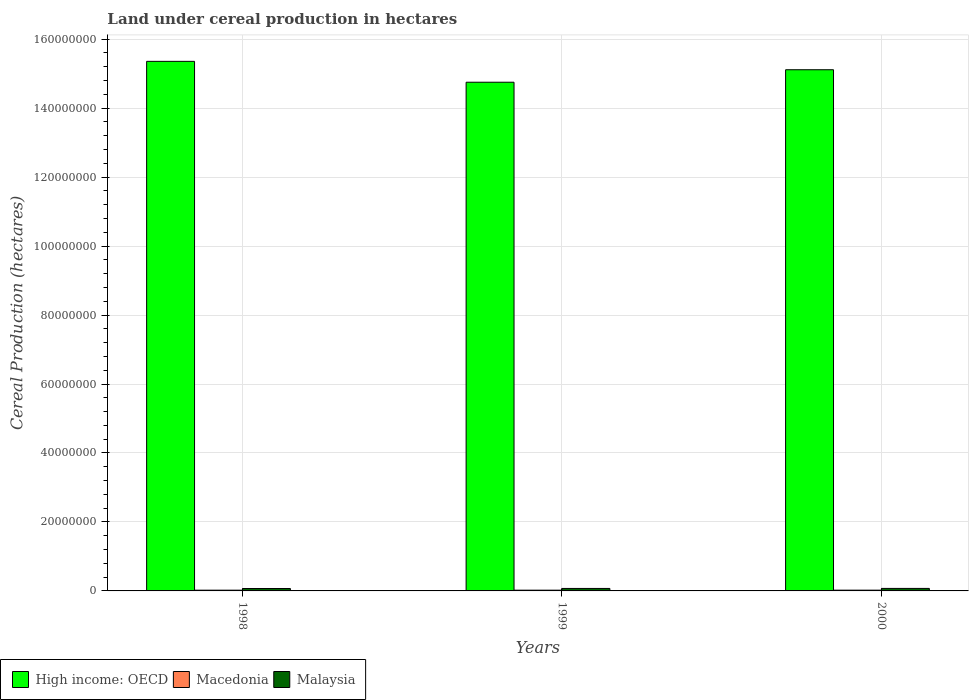How many groups of bars are there?
Provide a succinct answer. 3. Are the number of bars per tick equal to the number of legend labels?
Provide a short and direct response. Yes. Are the number of bars on each tick of the X-axis equal?
Your answer should be compact. Yes. How many bars are there on the 3rd tick from the right?
Offer a very short reply. 3. What is the label of the 3rd group of bars from the left?
Give a very brief answer. 2000. In how many cases, is the number of bars for a given year not equal to the number of legend labels?
Offer a very short reply. 0. What is the land under cereal production in Malaysia in 1998?
Give a very brief answer. 7.01e+05. Across all years, what is the maximum land under cereal production in Macedonia?
Your answer should be very brief. 2.20e+05. Across all years, what is the minimum land under cereal production in Macedonia?
Keep it short and to the point. 2.14e+05. In which year was the land under cereal production in Malaysia maximum?
Give a very brief answer. 2000. What is the total land under cereal production in High income: OECD in the graph?
Make the answer very short. 4.52e+08. What is the difference between the land under cereal production in Macedonia in 1998 and that in 2000?
Keep it short and to the point. -5616. What is the difference between the land under cereal production in High income: OECD in 2000 and the land under cereal production in Malaysia in 1999?
Give a very brief answer. 1.50e+08. What is the average land under cereal production in Malaysia per year?
Provide a short and direct response. 7.15e+05. In the year 1998, what is the difference between the land under cereal production in High income: OECD and land under cereal production in Macedonia?
Provide a short and direct response. 1.53e+08. In how many years, is the land under cereal production in High income: OECD greater than 28000000 hectares?
Your answer should be very brief. 3. What is the ratio of the land under cereal production in Macedonia in 1999 to that in 2000?
Your answer should be compact. 0.99. What is the difference between the highest and the second highest land under cereal production in Macedonia?
Provide a short and direct response. 2977. What is the difference between the highest and the lowest land under cereal production in Malaysia?
Provide a succinct answer. 2.43e+04. Is the sum of the land under cereal production in High income: OECD in 1999 and 2000 greater than the maximum land under cereal production in Malaysia across all years?
Keep it short and to the point. Yes. What does the 1st bar from the left in 1999 represents?
Your response must be concise. High income: OECD. What does the 1st bar from the right in 1998 represents?
Your answer should be compact. Malaysia. Is it the case that in every year, the sum of the land under cereal production in High income: OECD and land under cereal production in Macedonia is greater than the land under cereal production in Malaysia?
Offer a very short reply. Yes. Are all the bars in the graph horizontal?
Your answer should be very brief. No. How many years are there in the graph?
Keep it short and to the point. 3. Are the values on the major ticks of Y-axis written in scientific E-notation?
Keep it short and to the point. No. Does the graph contain any zero values?
Provide a short and direct response. No. Where does the legend appear in the graph?
Your answer should be compact. Bottom left. What is the title of the graph?
Provide a succinct answer. Land under cereal production in hectares. Does "Peru" appear as one of the legend labels in the graph?
Keep it short and to the point. No. What is the label or title of the Y-axis?
Your response must be concise. Cereal Production (hectares). What is the Cereal Production (hectares) of High income: OECD in 1998?
Ensure brevity in your answer.  1.54e+08. What is the Cereal Production (hectares) of Macedonia in 1998?
Offer a terse response. 2.14e+05. What is the Cereal Production (hectares) of Malaysia in 1998?
Provide a short and direct response. 7.01e+05. What is the Cereal Production (hectares) of High income: OECD in 1999?
Offer a terse response. 1.48e+08. What is the Cereal Production (hectares) of Macedonia in 1999?
Offer a very short reply. 2.17e+05. What is the Cereal Production (hectares) in Malaysia in 1999?
Your response must be concise. 7.19e+05. What is the Cereal Production (hectares) of High income: OECD in 2000?
Your answer should be very brief. 1.51e+08. What is the Cereal Production (hectares) in Macedonia in 2000?
Ensure brevity in your answer.  2.20e+05. What is the Cereal Production (hectares) of Malaysia in 2000?
Ensure brevity in your answer.  7.26e+05. Across all years, what is the maximum Cereal Production (hectares) of High income: OECD?
Provide a short and direct response. 1.54e+08. Across all years, what is the maximum Cereal Production (hectares) of Macedonia?
Offer a very short reply. 2.20e+05. Across all years, what is the maximum Cereal Production (hectares) of Malaysia?
Make the answer very short. 7.26e+05. Across all years, what is the minimum Cereal Production (hectares) of High income: OECD?
Your answer should be compact. 1.48e+08. Across all years, what is the minimum Cereal Production (hectares) of Macedonia?
Provide a succinct answer. 2.14e+05. Across all years, what is the minimum Cereal Production (hectares) of Malaysia?
Your answer should be compact. 7.01e+05. What is the total Cereal Production (hectares) in High income: OECD in the graph?
Provide a short and direct response. 4.52e+08. What is the total Cereal Production (hectares) in Macedonia in the graph?
Your response must be concise. 6.51e+05. What is the total Cereal Production (hectares) in Malaysia in the graph?
Your response must be concise. 2.15e+06. What is the difference between the Cereal Production (hectares) in High income: OECD in 1998 and that in 1999?
Give a very brief answer. 6.05e+06. What is the difference between the Cereal Production (hectares) in Macedonia in 1998 and that in 1999?
Offer a terse response. -2639. What is the difference between the Cereal Production (hectares) in Malaysia in 1998 and that in 1999?
Offer a terse response. -1.80e+04. What is the difference between the Cereal Production (hectares) in High income: OECD in 1998 and that in 2000?
Give a very brief answer. 2.43e+06. What is the difference between the Cereal Production (hectares) in Macedonia in 1998 and that in 2000?
Your response must be concise. -5616. What is the difference between the Cereal Production (hectares) of Malaysia in 1998 and that in 2000?
Your response must be concise. -2.43e+04. What is the difference between the Cereal Production (hectares) in High income: OECD in 1999 and that in 2000?
Your answer should be very brief. -3.62e+06. What is the difference between the Cereal Production (hectares) of Macedonia in 1999 and that in 2000?
Provide a succinct answer. -2977. What is the difference between the Cereal Production (hectares) in Malaysia in 1999 and that in 2000?
Your response must be concise. -6311. What is the difference between the Cereal Production (hectares) in High income: OECD in 1998 and the Cereal Production (hectares) in Macedonia in 1999?
Your answer should be very brief. 1.53e+08. What is the difference between the Cereal Production (hectares) of High income: OECD in 1998 and the Cereal Production (hectares) of Malaysia in 1999?
Provide a short and direct response. 1.53e+08. What is the difference between the Cereal Production (hectares) in Macedonia in 1998 and the Cereal Production (hectares) in Malaysia in 1999?
Your answer should be compact. -5.05e+05. What is the difference between the Cereal Production (hectares) in High income: OECD in 1998 and the Cereal Production (hectares) in Macedonia in 2000?
Your answer should be compact. 1.53e+08. What is the difference between the Cereal Production (hectares) of High income: OECD in 1998 and the Cereal Production (hectares) of Malaysia in 2000?
Keep it short and to the point. 1.53e+08. What is the difference between the Cereal Production (hectares) of Macedonia in 1998 and the Cereal Production (hectares) of Malaysia in 2000?
Make the answer very short. -5.11e+05. What is the difference between the Cereal Production (hectares) of High income: OECD in 1999 and the Cereal Production (hectares) of Macedonia in 2000?
Provide a short and direct response. 1.47e+08. What is the difference between the Cereal Production (hectares) of High income: OECD in 1999 and the Cereal Production (hectares) of Malaysia in 2000?
Provide a succinct answer. 1.47e+08. What is the difference between the Cereal Production (hectares) of Macedonia in 1999 and the Cereal Production (hectares) of Malaysia in 2000?
Make the answer very short. -5.09e+05. What is the average Cereal Production (hectares) of High income: OECD per year?
Give a very brief answer. 1.51e+08. What is the average Cereal Production (hectares) in Macedonia per year?
Your response must be concise. 2.17e+05. What is the average Cereal Production (hectares) in Malaysia per year?
Ensure brevity in your answer.  7.15e+05. In the year 1998, what is the difference between the Cereal Production (hectares) in High income: OECD and Cereal Production (hectares) in Macedonia?
Provide a succinct answer. 1.53e+08. In the year 1998, what is the difference between the Cereal Production (hectares) in High income: OECD and Cereal Production (hectares) in Malaysia?
Provide a short and direct response. 1.53e+08. In the year 1998, what is the difference between the Cereal Production (hectares) in Macedonia and Cereal Production (hectares) in Malaysia?
Keep it short and to the point. -4.87e+05. In the year 1999, what is the difference between the Cereal Production (hectares) in High income: OECD and Cereal Production (hectares) in Macedonia?
Offer a terse response. 1.47e+08. In the year 1999, what is the difference between the Cereal Production (hectares) in High income: OECD and Cereal Production (hectares) in Malaysia?
Make the answer very short. 1.47e+08. In the year 1999, what is the difference between the Cereal Production (hectares) in Macedonia and Cereal Production (hectares) in Malaysia?
Keep it short and to the point. -5.02e+05. In the year 2000, what is the difference between the Cereal Production (hectares) in High income: OECD and Cereal Production (hectares) in Macedonia?
Offer a very short reply. 1.51e+08. In the year 2000, what is the difference between the Cereal Production (hectares) of High income: OECD and Cereal Production (hectares) of Malaysia?
Your response must be concise. 1.50e+08. In the year 2000, what is the difference between the Cereal Production (hectares) in Macedonia and Cereal Production (hectares) in Malaysia?
Offer a very short reply. -5.06e+05. What is the ratio of the Cereal Production (hectares) of High income: OECD in 1998 to that in 1999?
Keep it short and to the point. 1.04. What is the ratio of the Cereal Production (hectares) in Malaysia in 1998 to that in 1999?
Your response must be concise. 0.97. What is the ratio of the Cereal Production (hectares) in High income: OECD in 1998 to that in 2000?
Your answer should be very brief. 1.02. What is the ratio of the Cereal Production (hectares) of Macedonia in 1998 to that in 2000?
Offer a very short reply. 0.97. What is the ratio of the Cereal Production (hectares) of Malaysia in 1998 to that in 2000?
Your answer should be very brief. 0.97. What is the ratio of the Cereal Production (hectares) of High income: OECD in 1999 to that in 2000?
Your answer should be compact. 0.98. What is the ratio of the Cereal Production (hectares) in Macedonia in 1999 to that in 2000?
Your answer should be very brief. 0.99. What is the ratio of the Cereal Production (hectares) in Malaysia in 1999 to that in 2000?
Ensure brevity in your answer.  0.99. What is the difference between the highest and the second highest Cereal Production (hectares) of High income: OECD?
Offer a terse response. 2.43e+06. What is the difference between the highest and the second highest Cereal Production (hectares) of Macedonia?
Provide a short and direct response. 2977. What is the difference between the highest and the second highest Cereal Production (hectares) of Malaysia?
Your answer should be very brief. 6311. What is the difference between the highest and the lowest Cereal Production (hectares) in High income: OECD?
Offer a terse response. 6.05e+06. What is the difference between the highest and the lowest Cereal Production (hectares) in Macedonia?
Give a very brief answer. 5616. What is the difference between the highest and the lowest Cereal Production (hectares) in Malaysia?
Provide a short and direct response. 2.43e+04. 